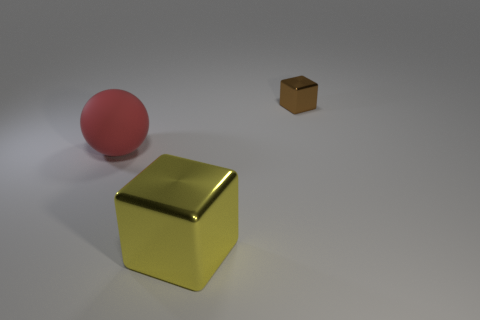Add 3 cyan rubber cylinders. How many objects exist? 6 Subtract all cubes. How many objects are left? 1 Subtract all tiny yellow metallic things. Subtract all red rubber spheres. How many objects are left? 2 Add 3 big red rubber balls. How many big red rubber balls are left? 4 Add 2 metallic objects. How many metallic objects exist? 4 Subtract 0 cyan spheres. How many objects are left? 3 